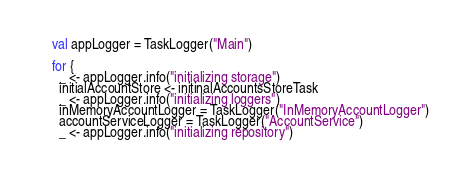Convert code to text. <code><loc_0><loc_0><loc_500><loc_500><_Scala_>
    val appLogger = TaskLogger("Main")

    for {
      _ <- appLogger.info("initializing storage")
      initialAccountStore <- initinalAccountsStoreTask
      _ <- appLogger.info("initializing loggers")
      inMemoryAccountLogger = TaskLogger("InMemoryAccountLogger")
      accountServiceLogger = TaskLogger("AccountService")
      _ <- appLogger.info("initializing repository")</code> 